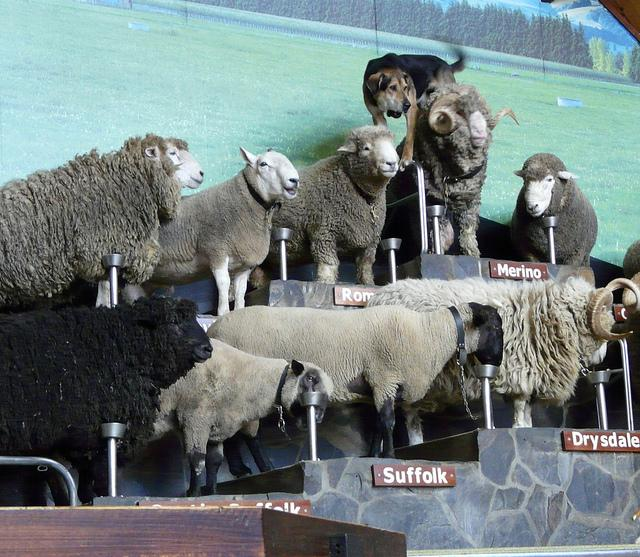What is at the top of the sheep pile? Please explain your reasoning. dog. All of the animals are clearly visible and answer a is consistent with the location given in the question and is identifiable based on its known features, shape and size. 